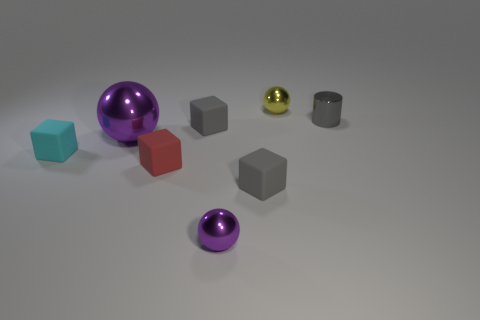Subtract all cyan cubes. How many cubes are left? 3 Add 1 big gray things. How many objects exist? 9 Subtract all yellow balls. How many balls are left? 2 Subtract all gray blocks. How many purple balls are left? 2 Subtract all cylinders. How many objects are left? 7 Subtract 2 cubes. How many cubes are left? 2 Subtract all blue blocks. Subtract all gray spheres. How many blocks are left? 4 Subtract all yellow balls. Subtract all gray cubes. How many objects are left? 5 Add 5 big purple shiny objects. How many big purple shiny objects are left? 6 Add 8 gray shiny cylinders. How many gray shiny cylinders exist? 9 